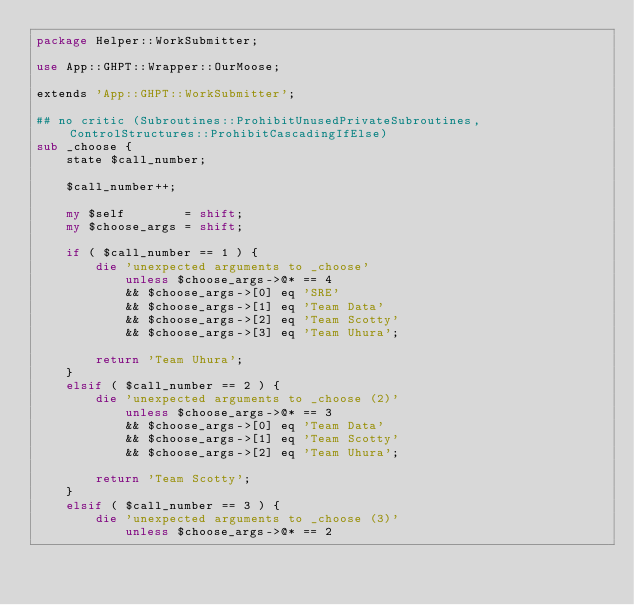Convert code to text. <code><loc_0><loc_0><loc_500><loc_500><_Perl_>package Helper::WorkSubmitter;

use App::GHPT::Wrapper::OurMoose;

extends 'App::GHPT::WorkSubmitter';

## no critic (Subroutines::ProhibitUnusedPrivateSubroutines, ControlStructures::ProhibitCascadingIfElse)
sub _choose {
    state $call_number;

    $call_number++;

    my $self        = shift;
    my $choose_args = shift;

    if ( $call_number == 1 ) {
        die 'unexpected arguments to _choose'
            unless $choose_args->@* == 4
            && $choose_args->[0] eq 'SRE'
            && $choose_args->[1] eq 'Team Data'
            && $choose_args->[2] eq 'Team Scotty'
            && $choose_args->[3] eq 'Team Uhura';

        return 'Team Uhura';
    }
    elsif ( $call_number == 2 ) {
        die 'unexpected arguments to _choose (2)'
            unless $choose_args->@* == 3
            && $choose_args->[0] eq 'Team Data'
            && $choose_args->[1] eq 'Team Scotty'
            && $choose_args->[2] eq 'Team Uhura';

        return 'Team Scotty';
    }
    elsif ( $call_number == 3 ) {
        die 'unexpected arguments to _choose (3)'
            unless $choose_args->@* == 2</code> 